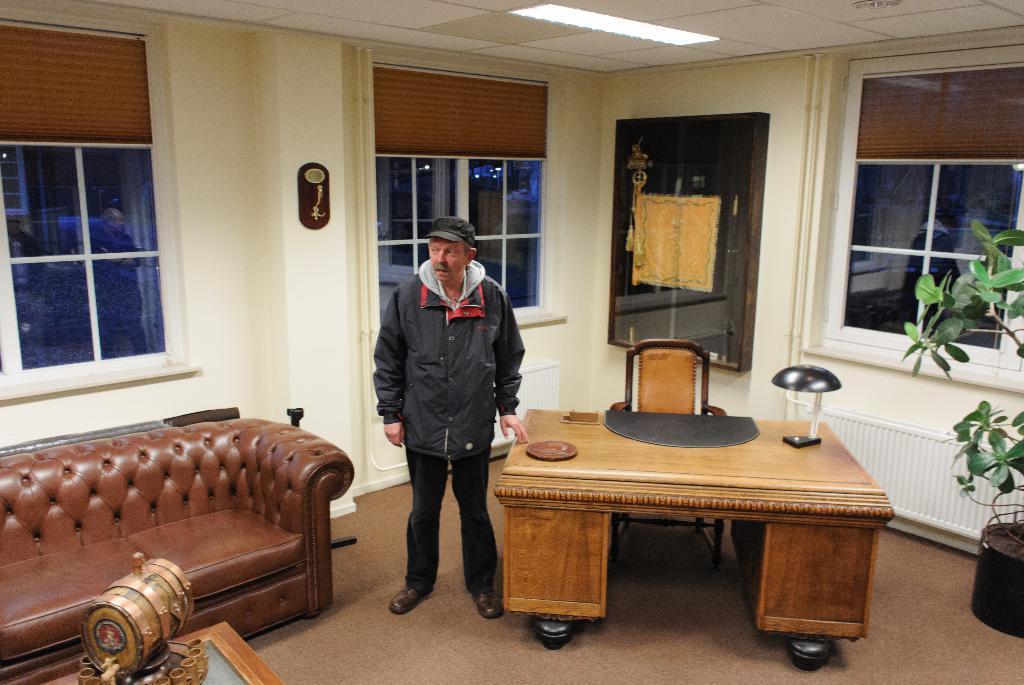Describe this image in one or two sentences. There is a room. The person standing in a room. He is wearing a colorful black jacket. He is wearing a cap. There is a table. There is a mat ,glass on a table. We can see in background window,curtain and flower plant. 